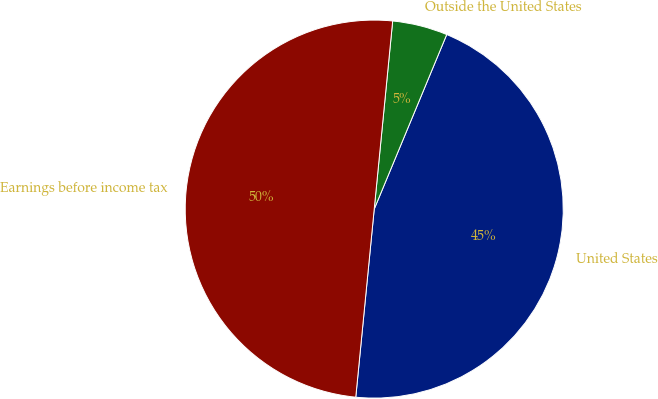<chart> <loc_0><loc_0><loc_500><loc_500><pie_chart><fcel>United States<fcel>Outside the United States<fcel>Earnings before income tax<nl><fcel>45.29%<fcel>4.71%<fcel>50.0%<nl></chart> 